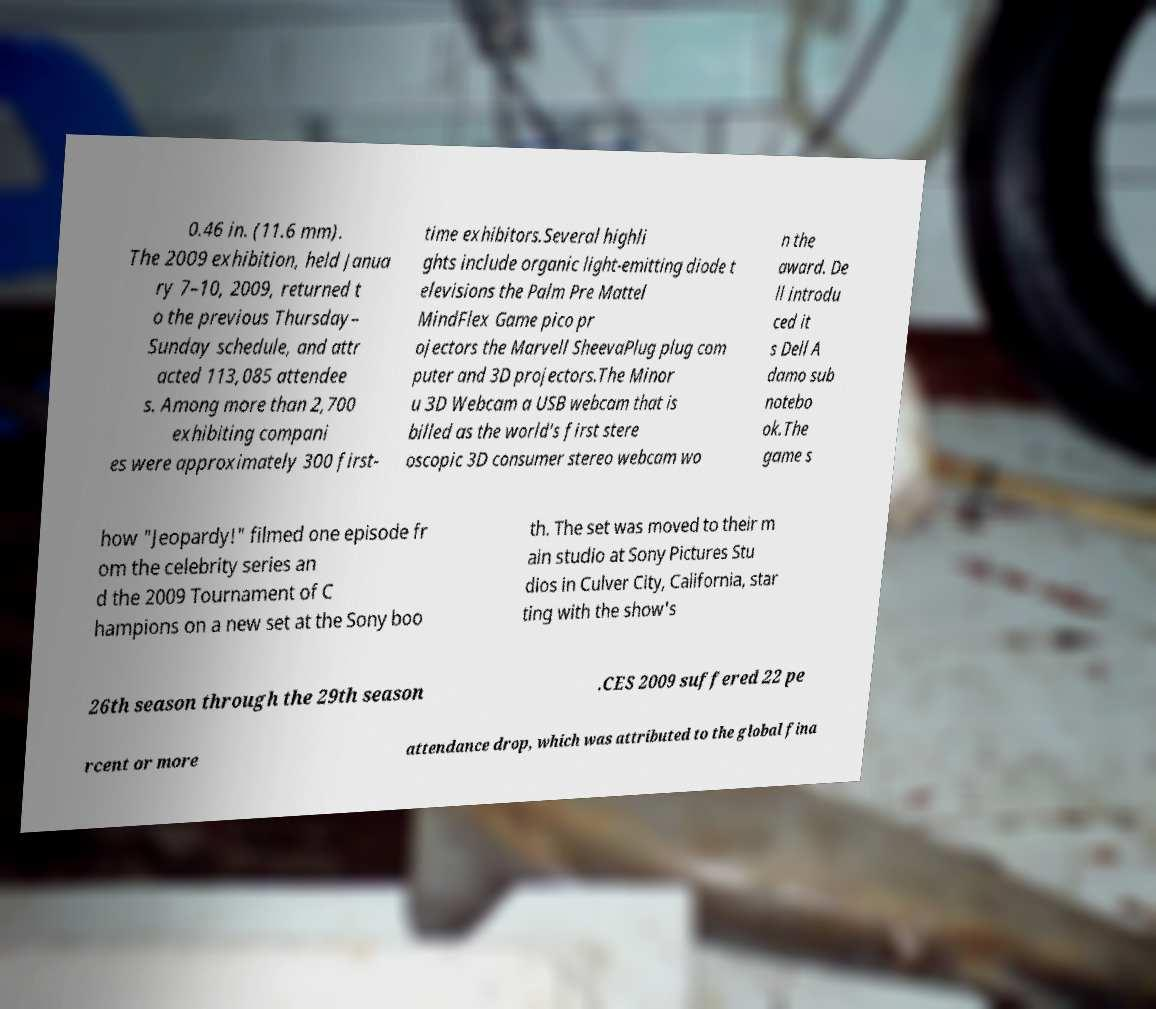Could you extract and type out the text from this image? 0.46 in. (11.6 mm). The 2009 exhibition, held Janua ry 7–10, 2009, returned t o the previous Thursday– Sunday schedule, and attr acted 113,085 attendee s. Among more than 2,700 exhibiting compani es were approximately 300 first- time exhibitors.Several highli ghts include organic light-emitting diode t elevisions the Palm Pre Mattel MindFlex Game pico pr ojectors the Marvell SheevaPlug plug com puter and 3D projectors.The Minor u 3D Webcam a USB webcam that is billed as the world's first stere oscopic 3D consumer stereo webcam wo n the award. De ll introdu ced it s Dell A damo sub notebo ok.The game s how "Jeopardy!" filmed one episode fr om the celebrity series an d the 2009 Tournament of C hampions on a new set at the Sony boo th. The set was moved to their m ain studio at Sony Pictures Stu dios in Culver City, California, star ting with the show's 26th season through the 29th season .CES 2009 suffered 22 pe rcent or more attendance drop, which was attributed to the global fina 